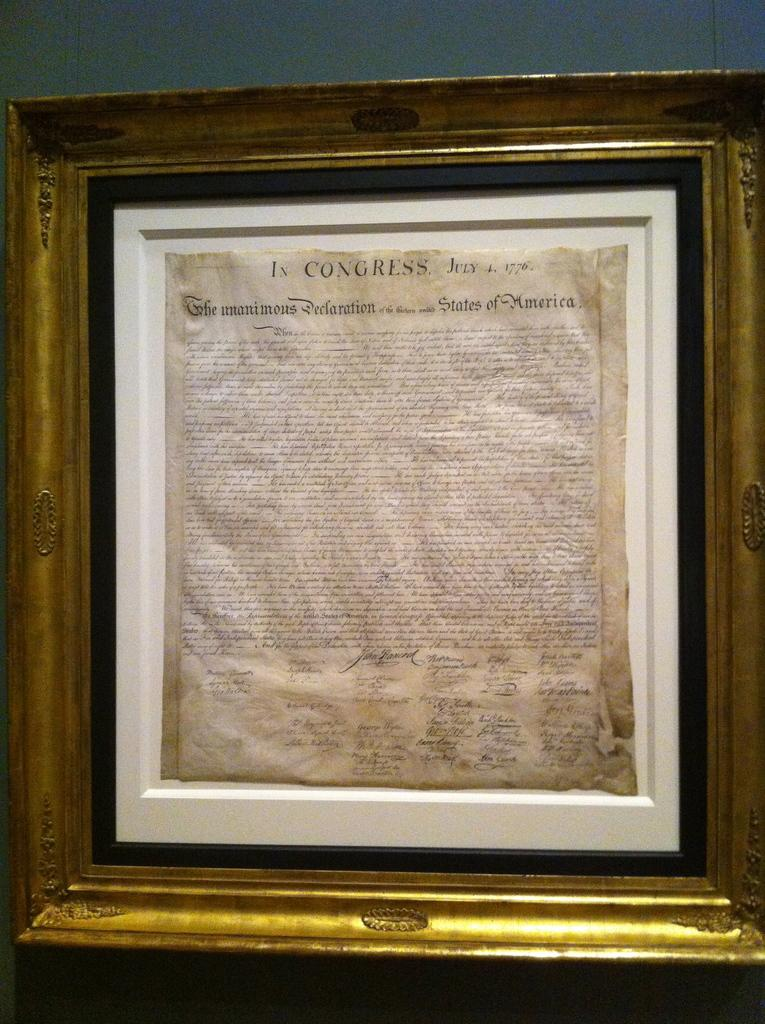<image>
Summarize the visual content of the image. A guilded framed copy of the Declaration of Independance of the USA. 